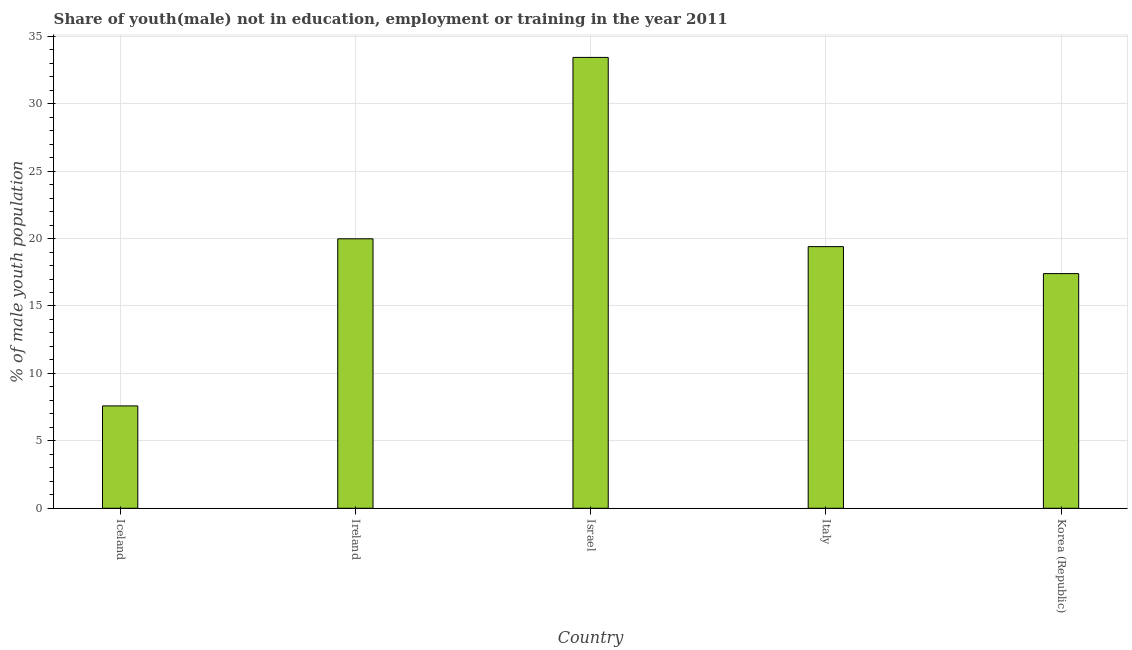Does the graph contain any zero values?
Provide a short and direct response. No. What is the title of the graph?
Your response must be concise. Share of youth(male) not in education, employment or training in the year 2011. What is the label or title of the Y-axis?
Your response must be concise. % of male youth population. What is the unemployed male youth population in Iceland?
Offer a very short reply. 7.59. Across all countries, what is the maximum unemployed male youth population?
Give a very brief answer. 33.43. Across all countries, what is the minimum unemployed male youth population?
Offer a very short reply. 7.59. In which country was the unemployed male youth population minimum?
Ensure brevity in your answer.  Iceland. What is the sum of the unemployed male youth population?
Offer a terse response. 97.8. What is the difference between the unemployed male youth population in Iceland and Israel?
Make the answer very short. -25.84. What is the average unemployed male youth population per country?
Provide a short and direct response. 19.56. What is the median unemployed male youth population?
Give a very brief answer. 19.4. What is the ratio of the unemployed male youth population in Iceland to that in Israel?
Your answer should be compact. 0.23. Is the difference between the unemployed male youth population in Israel and Korea (Republic) greater than the difference between any two countries?
Your answer should be compact. No. What is the difference between the highest and the second highest unemployed male youth population?
Give a very brief answer. 13.45. What is the difference between the highest and the lowest unemployed male youth population?
Keep it short and to the point. 25.84. In how many countries, is the unemployed male youth population greater than the average unemployed male youth population taken over all countries?
Your answer should be compact. 2. How many countries are there in the graph?
Keep it short and to the point. 5. What is the difference between two consecutive major ticks on the Y-axis?
Your answer should be very brief. 5. What is the % of male youth population of Iceland?
Provide a short and direct response. 7.59. What is the % of male youth population of Ireland?
Your response must be concise. 19.98. What is the % of male youth population in Israel?
Give a very brief answer. 33.43. What is the % of male youth population of Italy?
Your answer should be very brief. 19.4. What is the % of male youth population in Korea (Republic)?
Make the answer very short. 17.4. What is the difference between the % of male youth population in Iceland and Ireland?
Keep it short and to the point. -12.39. What is the difference between the % of male youth population in Iceland and Israel?
Offer a very short reply. -25.84. What is the difference between the % of male youth population in Iceland and Italy?
Give a very brief answer. -11.81. What is the difference between the % of male youth population in Iceland and Korea (Republic)?
Offer a terse response. -9.81. What is the difference between the % of male youth population in Ireland and Israel?
Your answer should be very brief. -13.45. What is the difference between the % of male youth population in Ireland and Italy?
Provide a succinct answer. 0.58. What is the difference between the % of male youth population in Ireland and Korea (Republic)?
Give a very brief answer. 2.58. What is the difference between the % of male youth population in Israel and Italy?
Keep it short and to the point. 14.03. What is the difference between the % of male youth population in Israel and Korea (Republic)?
Offer a very short reply. 16.03. What is the difference between the % of male youth population in Italy and Korea (Republic)?
Keep it short and to the point. 2. What is the ratio of the % of male youth population in Iceland to that in Ireland?
Give a very brief answer. 0.38. What is the ratio of the % of male youth population in Iceland to that in Israel?
Your response must be concise. 0.23. What is the ratio of the % of male youth population in Iceland to that in Italy?
Provide a short and direct response. 0.39. What is the ratio of the % of male youth population in Iceland to that in Korea (Republic)?
Keep it short and to the point. 0.44. What is the ratio of the % of male youth population in Ireland to that in Israel?
Give a very brief answer. 0.6. What is the ratio of the % of male youth population in Ireland to that in Italy?
Provide a short and direct response. 1.03. What is the ratio of the % of male youth population in Ireland to that in Korea (Republic)?
Offer a very short reply. 1.15. What is the ratio of the % of male youth population in Israel to that in Italy?
Provide a succinct answer. 1.72. What is the ratio of the % of male youth population in Israel to that in Korea (Republic)?
Ensure brevity in your answer.  1.92. What is the ratio of the % of male youth population in Italy to that in Korea (Republic)?
Provide a short and direct response. 1.11. 